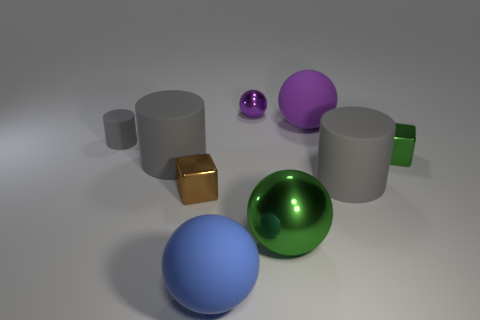Add 1 small purple metallic objects. How many objects exist? 10 Subtract all spheres. How many objects are left? 5 Add 4 large yellow objects. How many large yellow objects exist? 4 Subtract 0 purple blocks. How many objects are left? 9 Subtract all big green shiny cylinders. Subtract all tiny brown metallic cubes. How many objects are left? 8 Add 6 purple matte things. How many purple matte things are left? 7 